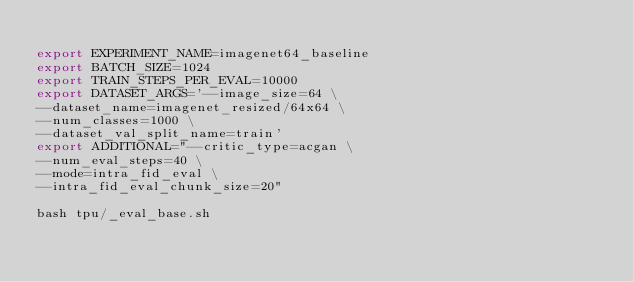<code> <loc_0><loc_0><loc_500><loc_500><_Bash_>
export EXPERIMENT_NAME=imagenet64_baseline
export BATCH_SIZE=1024
export TRAIN_STEPS_PER_EVAL=10000
export DATASET_ARGS='--image_size=64 \
--dataset_name=imagenet_resized/64x64 \
--num_classes=1000 \
--dataset_val_split_name=train'
export ADDITIONAL="--critic_type=acgan \
--num_eval_steps=40 \
--mode=intra_fid_eval \
--intra_fid_eval_chunk_size=20"

bash tpu/_eval_base.sh

</code> 